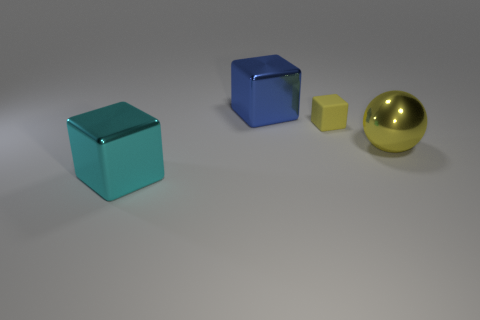Subtract all metal blocks. How many blocks are left? 1 Add 4 metallic cubes. How many metallic cubes exist? 6 Add 2 purple metallic objects. How many objects exist? 6 Subtract all yellow cubes. How many cubes are left? 2 Subtract 1 blue blocks. How many objects are left? 3 Subtract all spheres. How many objects are left? 3 Subtract 1 cubes. How many cubes are left? 2 Subtract all purple balls. Subtract all blue blocks. How many balls are left? 1 Subtract all cyan cylinders. How many blue cubes are left? 1 Subtract all big blue blocks. Subtract all blue metallic blocks. How many objects are left? 2 